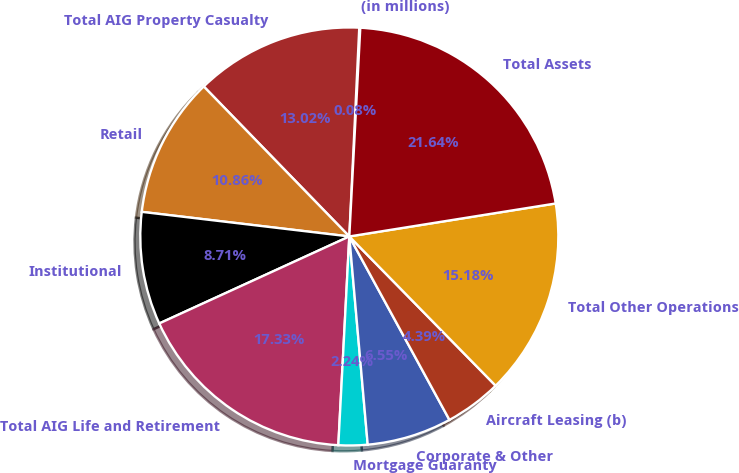Convert chart. <chart><loc_0><loc_0><loc_500><loc_500><pie_chart><fcel>(in millions)<fcel>Total AIG Property Casualty<fcel>Retail<fcel>Institutional<fcel>Total AIG Life and Retirement<fcel>Mortgage Guaranty<fcel>Corporate & Other<fcel>Aircraft Leasing (b)<fcel>Total Other Operations<fcel>Total Assets<nl><fcel>0.08%<fcel>13.02%<fcel>10.86%<fcel>8.71%<fcel>17.33%<fcel>2.24%<fcel>6.55%<fcel>4.39%<fcel>15.18%<fcel>21.64%<nl></chart> 